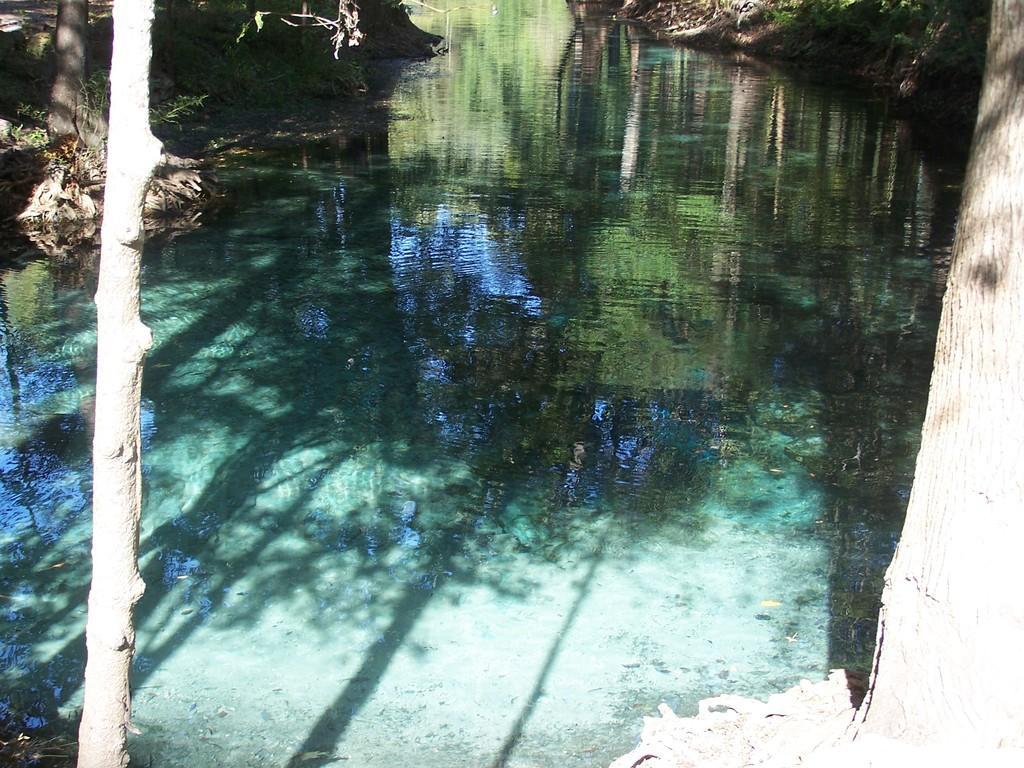In one or two sentences, can you explain what this image depicts? In the center of the image water is present. On the left and right side of the image trees, grass are present. At the top left corner ground is there. 